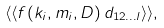<formula> <loc_0><loc_0><loc_500><loc_500>\langle \langle f ( k _ { i } , m _ { i } , D ) \, d _ { 1 2 \dots l } \rangle \rangle ,</formula> 